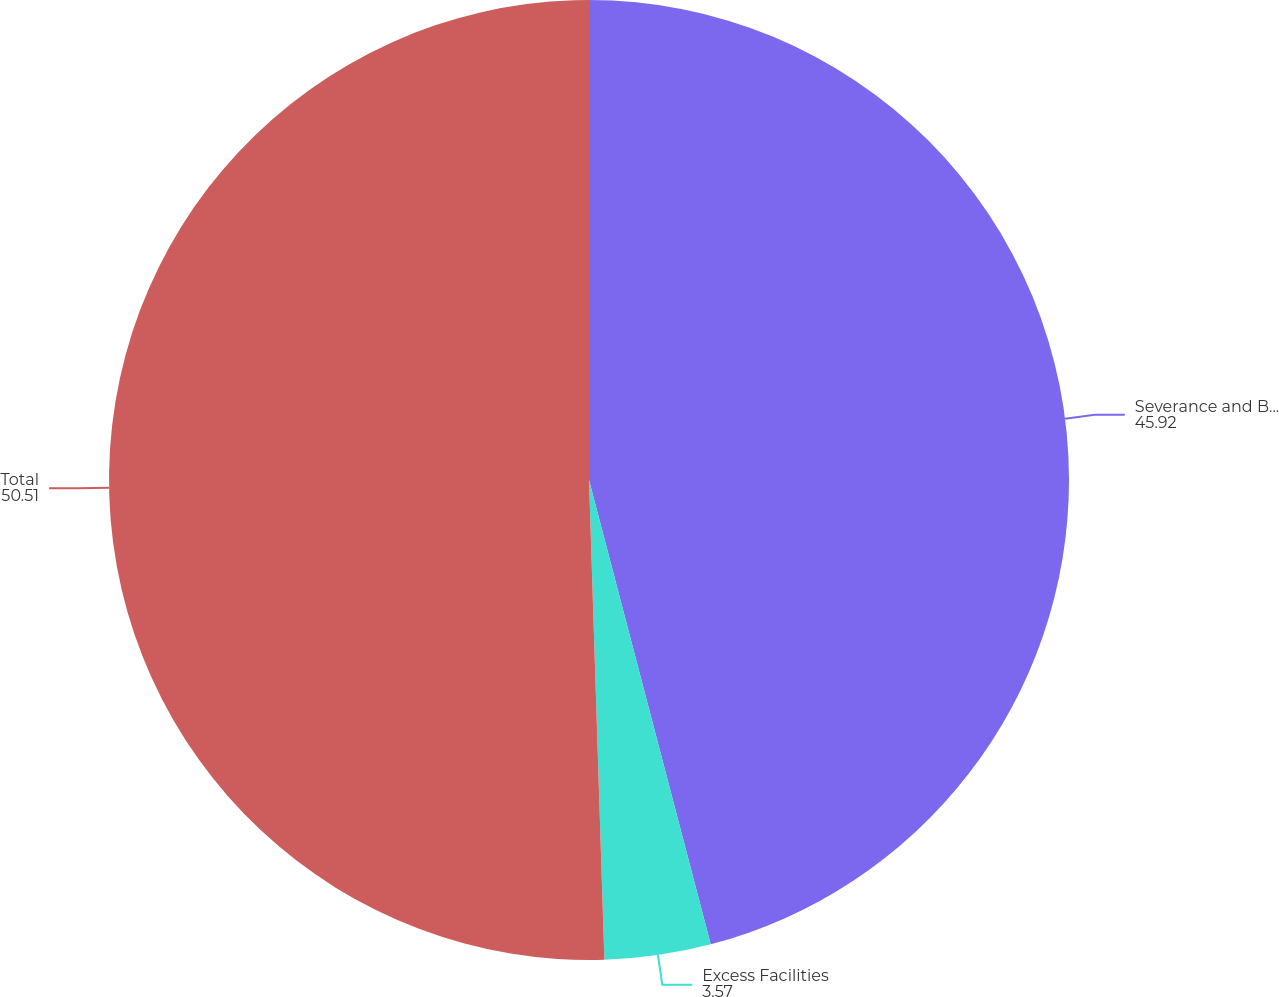Convert chart. <chart><loc_0><loc_0><loc_500><loc_500><pie_chart><fcel>Severance and Benefits<fcel>Excess Facilities<fcel>Total<nl><fcel>45.92%<fcel>3.57%<fcel>50.51%<nl></chart> 